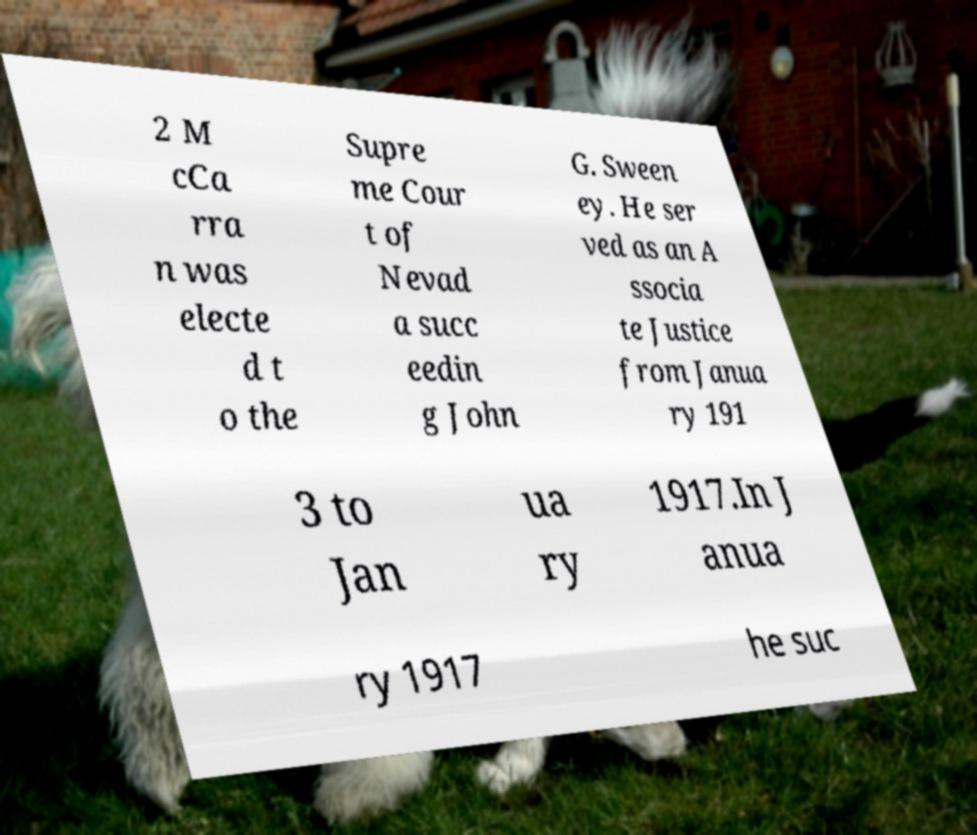For documentation purposes, I need the text within this image transcribed. Could you provide that? 2 M cCa rra n was electe d t o the Supre me Cour t of Nevad a succ eedin g John G. Sween ey. He ser ved as an A ssocia te Justice from Janua ry 191 3 to Jan ua ry 1917.In J anua ry 1917 he suc 